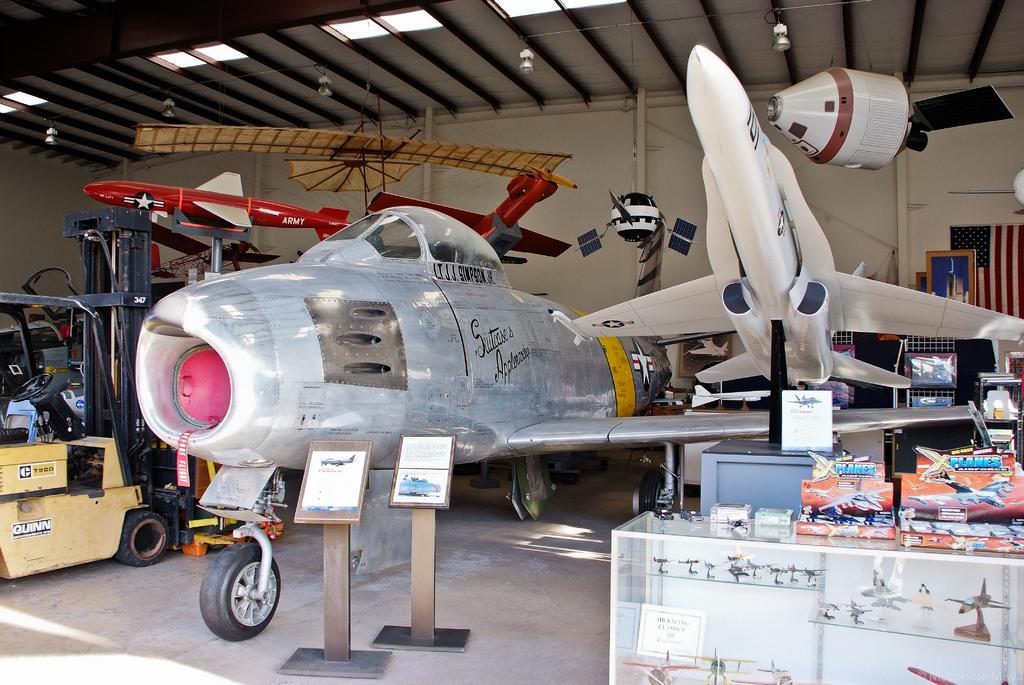How would you summarize this image in a sentence or two? This is an inside view. Here I can see few aircrafts on the right side there is a table on which many boxes are placed. On the left side there is a vehicle on the floor. In the background there are many objects and also I can see the wall. At the top of the image there are few lights. 